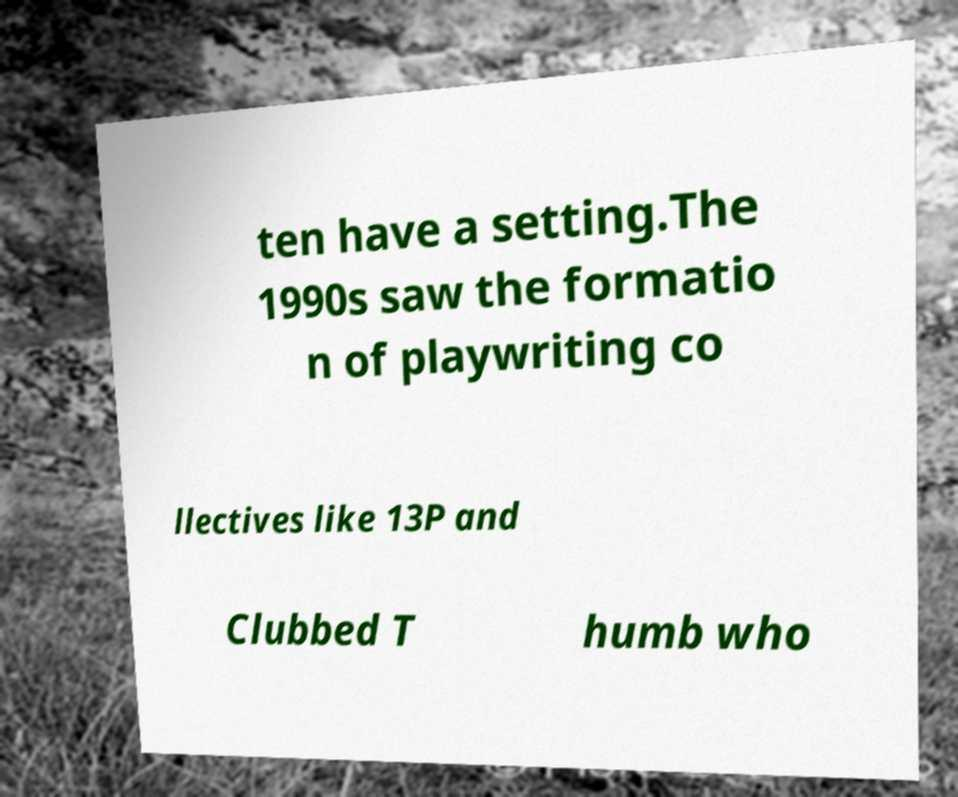Can you accurately transcribe the text from the provided image for me? ten have a setting.The 1990s saw the formatio n of playwriting co llectives like 13P and Clubbed T humb who 